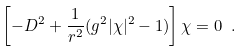<formula> <loc_0><loc_0><loc_500><loc_500>\left [ - D ^ { 2 } + \frac { 1 } { r ^ { 2 } } ( g ^ { 2 } | \chi | ^ { 2 } - 1 ) \right ] \chi = 0 \ .</formula> 